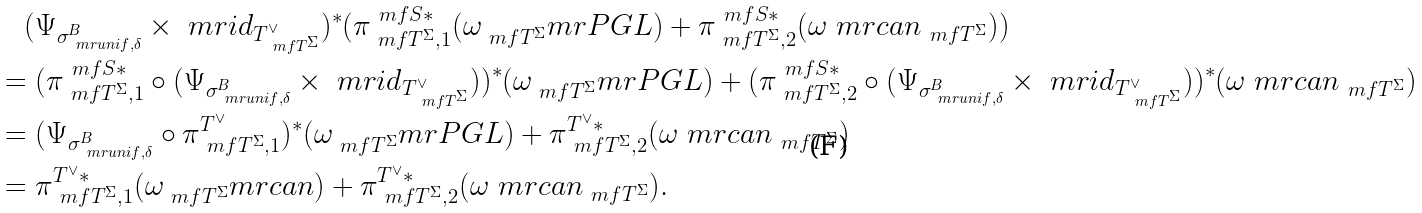<formula> <loc_0><loc_0><loc_500><loc_500>& \quad ( \Psi _ { \sigma _ { \ m r { u n i f } , \delta } ^ { B } } \times \ m r { i d } _ { T ^ { \vee } _ { \ m f T ^ { \Sigma } } } ) ^ { * } ( \pi ^ { \ m f S * } _ { \ m f T ^ { \Sigma } , 1 } ( \omega _ { \ m f T ^ { \Sigma } } ^ { \ } m r { P G L } ) + \pi ^ { \ m f S * } _ { \ m f T ^ { \Sigma } , 2 } ( \omega ^ { \ } m r { c a n } _ { \ m f T ^ { \Sigma } } ) ) \\ & = ( \pi ^ { \ m f S * } _ { \ m f T ^ { \Sigma } , 1 } \circ ( \Psi _ { \sigma _ { \ m r { u n i f } , \delta } ^ { B } } \times \ m r { i d } _ { T ^ { \vee } _ { \ m f T ^ { \Sigma } } } ) ) ^ { * } ( \omega _ { \ m f T ^ { \Sigma } } ^ { \ } m r { P G L } ) + ( \pi ^ { \ m f S * } _ { \ m f T ^ { \Sigma } , 2 } \circ ( \Psi _ { \sigma _ { \ m r { u n i f } , \delta } ^ { B } } \times \ m r { i d } _ { T ^ { \vee } _ { \ m f T ^ { \Sigma } } } ) ) ^ { * } ( \omega ^ { \ } m r { c a n } _ { \ m f T ^ { \Sigma } } ) \\ & = ( \Psi _ { \sigma _ { \ m r { u n i f } , \delta } ^ { B } } \circ \pi ^ { T ^ { \vee } } _ { \ m f T ^ { \Sigma } , 1 } ) ^ { * } ( \omega _ { \ m f T ^ { \Sigma } } ^ { \ } m r { P G L } ) + \pi ^ { T ^ { \vee } * } _ { \ m f T ^ { \Sigma } , 2 } ( \omega ^ { \ } m r { c a n } _ { \ m f T ^ { \Sigma } } ) \\ & = \pi ^ { T ^ { \vee } * } _ { \ m f T ^ { \Sigma } , 1 } ( \omega _ { \ m f T ^ { \Sigma } } ^ { \ } m r { c a n } ) + \pi ^ { T ^ { \vee } * } _ { \ m f T ^ { \Sigma } , 2 } ( \omega ^ { \ } m r { c a n } _ { \ m f T ^ { \Sigma } } ) .</formula> 